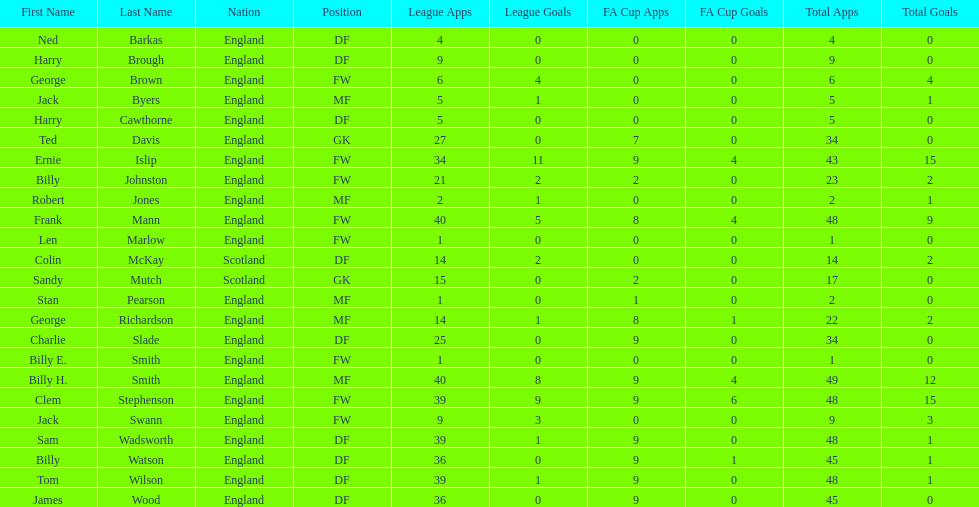What is the last name listed on this chart? James Wood. 